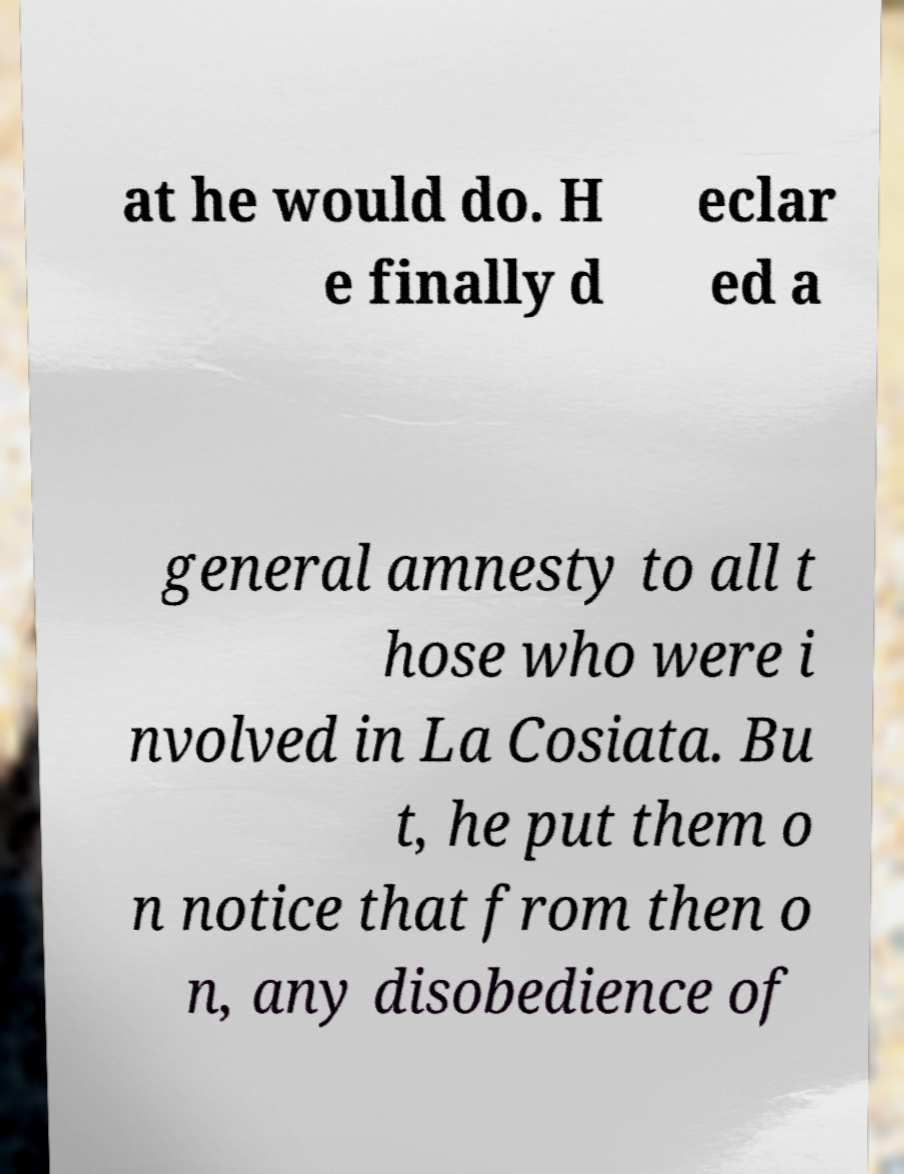Please read and relay the text visible in this image. What does it say? at he would do. H e finally d eclar ed a general amnesty to all t hose who were i nvolved in La Cosiata. Bu t, he put them o n notice that from then o n, any disobedience of 